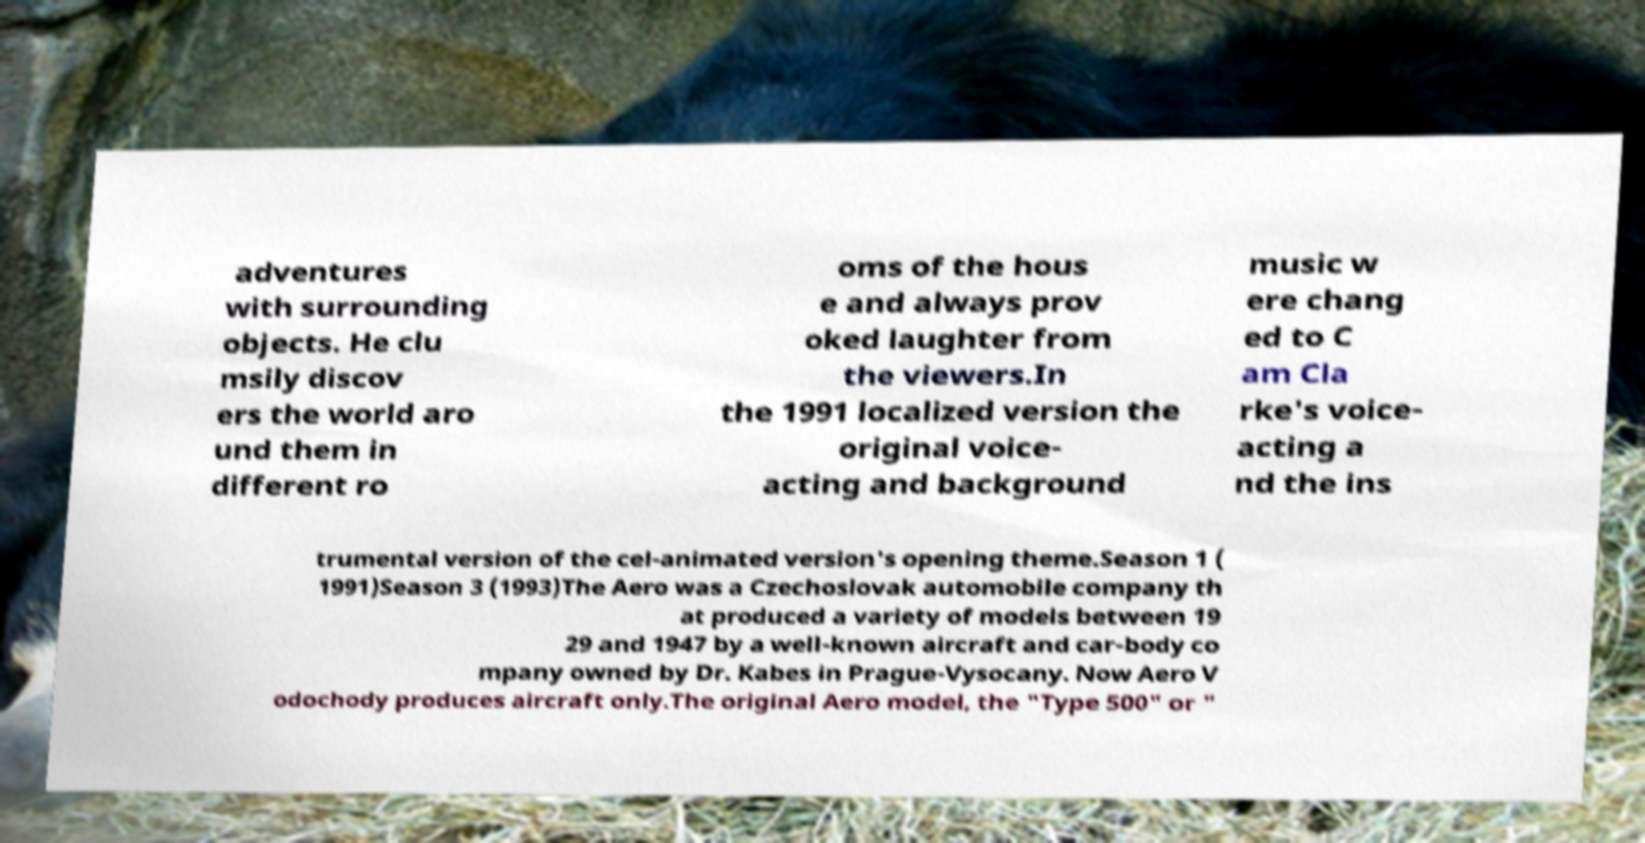For documentation purposes, I need the text within this image transcribed. Could you provide that? adventures with surrounding objects. He clu msily discov ers the world aro und them in different ro oms of the hous e and always prov oked laughter from the viewers.In the 1991 localized version the original voice- acting and background music w ere chang ed to C am Cla rke's voice- acting a nd the ins trumental version of the cel-animated version's opening theme.Season 1 ( 1991)Season 3 (1993)The Aero was a Czechoslovak automobile company th at produced a variety of models between 19 29 and 1947 by a well-known aircraft and car-body co mpany owned by Dr. Kabes in Prague-Vysocany. Now Aero V odochody produces aircraft only.The original Aero model, the "Type 500" or " 